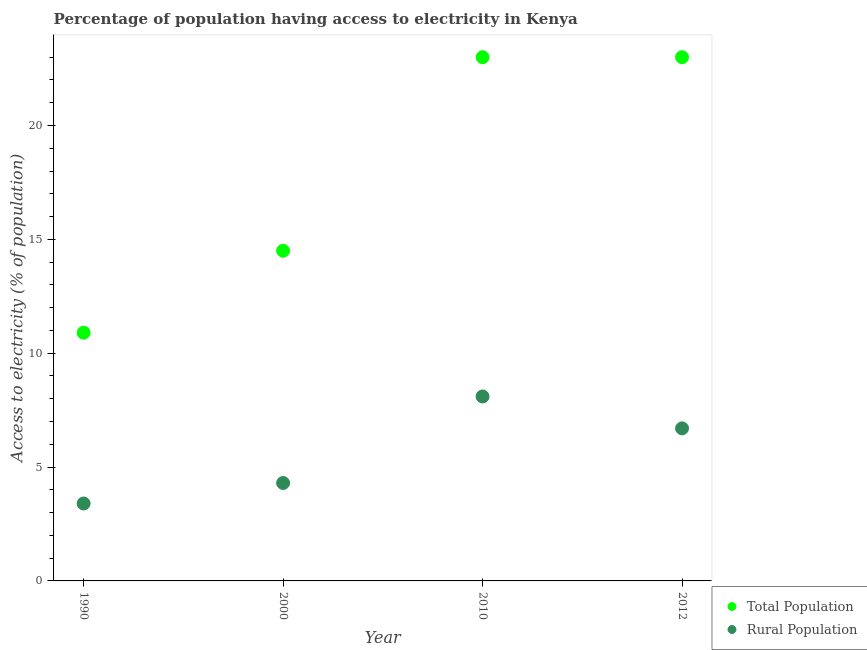How many different coloured dotlines are there?
Your answer should be very brief. 2. What is the percentage of population having access to electricity in 2012?
Provide a short and direct response. 23. Across all years, what is the maximum percentage of population having access to electricity?
Your answer should be compact. 23. In which year was the percentage of population having access to electricity maximum?
Ensure brevity in your answer.  2010. What is the total percentage of population having access to electricity in the graph?
Your response must be concise. 71.4. What is the difference between the percentage of population having access to electricity in 2012 and the percentage of rural population having access to electricity in 2000?
Ensure brevity in your answer.  18.7. What is the average percentage of rural population having access to electricity per year?
Your response must be concise. 5.62. In how many years, is the percentage of population having access to electricity greater than 22 %?
Your response must be concise. 2. What is the ratio of the percentage of population having access to electricity in 2000 to that in 2010?
Keep it short and to the point. 0.63. Is the difference between the percentage of population having access to electricity in 2000 and 2012 greater than the difference between the percentage of rural population having access to electricity in 2000 and 2012?
Provide a short and direct response. No. What is the difference between the highest and the second highest percentage of rural population having access to electricity?
Ensure brevity in your answer.  1.4. What is the difference between the highest and the lowest percentage of rural population having access to electricity?
Give a very brief answer. 4.7. What is the difference between two consecutive major ticks on the Y-axis?
Your response must be concise. 5. Does the graph contain any zero values?
Your answer should be very brief. No. Does the graph contain grids?
Provide a succinct answer. No. Where does the legend appear in the graph?
Offer a very short reply. Bottom right. What is the title of the graph?
Offer a very short reply. Percentage of population having access to electricity in Kenya. What is the label or title of the X-axis?
Your answer should be compact. Year. What is the label or title of the Y-axis?
Provide a succinct answer. Access to electricity (% of population). What is the Access to electricity (% of population) in Total Population in 1990?
Your answer should be very brief. 10.9. What is the Access to electricity (% of population) of Rural Population in 1990?
Ensure brevity in your answer.  3.4. What is the Access to electricity (% of population) in Total Population in 2012?
Your response must be concise. 23. Across all years, what is the maximum Access to electricity (% of population) in Rural Population?
Ensure brevity in your answer.  8.1. Across all years, what is the minimum Access to electricity (% of population) of Rural Population?
Provide a short and direct response. 3.4. What is the total Access to electricity (% of population) in Total Population in the graph?
Make the answer very short. 71.4. What is the total Access to electricity (% of population) in Rural Population in the graph?
Provide a succinct answer. 22.5. What is the difference between the Access to electricity (% of population) in Rural Population in 1990 and that in 2000?
Provide a short and direct response. -0.9. What is the difference between the Access to electricity (% of population) in Total Population in 1990 and that in 2012?
Offer a very short reply. -12.1. What is the difference between the Access to electricity (% of population) of Total Population in 2000 and that in 2010?
Your answer should be very brief. -8.5. What is the difference between the Access to electricity (% of population) of Total Population in 2010 and that in 2012?
Offer a very short reply. 0. What is the difference between the Access to electricity (% of population) of Total Population in 1990 and the Access to electricity (% of population) of Rural Population in 2000?
Ensure brevity in your answer.  6.6. What is the difference between the Access to electricity (% of population) of Total Population in 1990 and the Access to electricity (% of population) of Rural Population in 2012?
Ensure brevity in your answer.  4.2. What is the average Access to electricity (% of population) of Total Population per year?
Provide a short and direct response. 17.85. What is the average Access to electricity (% of population) of Rural Population per year?
Make the answer very short. 5.62. In the year 1990, what is the difference between the Access to electricity (% of population) in Total Population and Access to electricity (% of population) in Rural Population?
Your answer should be compact. 7.5. In the year 2000, what is the difference between the Access to electricity (% of population) of Total Population and Access to electricity (% of population) of Rural Population?
Ensure brevity in your answer.  10.2. What is the ratio of the Access to electricity (% of population) of Total Population in 1990 to that in 2000?
Ensure brevity in your answer.  0.75. What is the ratio of the Access to electricity (% of population) of Rural Population in 1990 to that in 2000?
Offer a very short reply. 0.79. What is the ratio of the Access to electricity (% of population) in Total Population in 1990 to that in 2010?
Your response must be concise. 0.47. What is the ratio of the Access to electricity (% of population) of Rural Population in 1990 to that in 2010?
Make the answer very short. 0.42. What is the ratio of the Access to electricity (% of population) of Total Population in 1990 to that in 2012?
Your answer should be compact. 0.47. What is the ratio of the Access to electricity (% of population) of Rural Population in 1990 to that in 2012?
Your response must be concise. 0.51. What is the ratio of the Access to electricity (% of population) in Total Population in 2000 to that in 2010?
Provide a short and direct response. 0.63. What is the ratio of the Access to electricity (% of population) in Rural Population in 2000 to that in 2010?
Offer a very short reply. 0.53. What is the ratio of the Access to electricity (% of population) in Total Population in 2000 to that in 2012?
Provide a succinct answer. 0.63. What is the ratio of the Access to electricity (% of population) of Rural Population in 2000 to that in 2012?
Offer a terse response. 0.64. What is the ratio of the Access to electricity (% of population) of Rural Population in 2010 to that in 2012?
Make the answer very short. 1.21. What is the difference between the highest and the second highest Access to electricity (% of population) of Total Population?
Offer a very short reply. 0. What is the difference between the highest and the lowest Access to electricity (% of population) of Rural Population?
Make the answer very short. 4.7. 